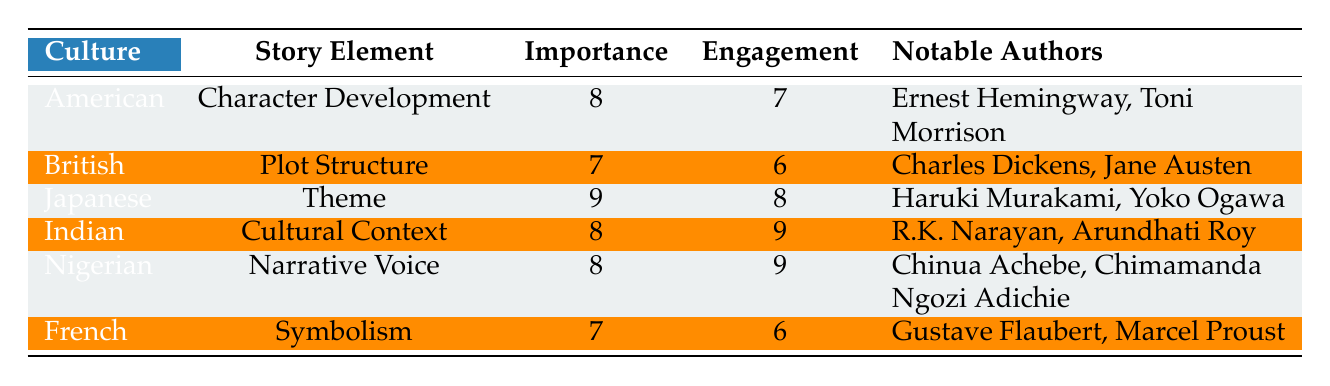What is the importance rating for the Japanese culture's story element? The table shows that for the Japanese culture's story element, the Importance Rating is listed directly as 9.
Answer: 9 Which culture has the highest reader engagement rating? The table indicates that the Indian culture has a Reader Engagement score of 9, which is the highest among all cultures listed.
Answer: Indian How many notable authors are associated with the American culture's story element? The table lists two notable authors for the American culture, which are Ernest Hemingway and Toni Morrison.
Answer: 2 What is the difference between the highest and lowest importance ratings across cultures? The highest Importance Rating is 9 (Japanese), and the lowest is 7 (British and French). The difference is therefore 9 - 7 = 2.
Answer: 2 Do Nigerian authors focus on character development in their stories? The table shows that the Nigerian culture emphasizes "Narrative Voice," not "Character Development," indicating that they do not primarily focus on character development.
Answer: No What is the average reader engagement rating across all the cultures listed? To find the average, sum all the Reader Engagement scores: (7 + 6 + 8 + 9 + 9 + 6) = 45. Since there are 6 cultures, divide 45 by 6, which results in an average of 7.5.
Answer: 7.5 Does every culture emphasize the importance of "Character Development"? According to the table, only the American culture emphasizes "Character Development," while others focus on different story elements, indicating that not every culture emphasizes it.
Answer: No What story element do both Indian and Nigerian cultures find equally important? Both cultures have an Importance Rating of 8, showing that they equally prioritize "Cultural Context" (Indian) and "Narrative Voice" (Nigerian) and illustrate how different elements can be considered important similarly.
Answer: N/A (Both are equally important but represent different elements) Which culture's notable authors are focused on themes in their works? The table specifically lists Japanese authors, Haruki Murakami and Yoko Ogawa, who are associated with the story element "Theme," indicating that their works focus on this aspect.
Answer: Japanese 